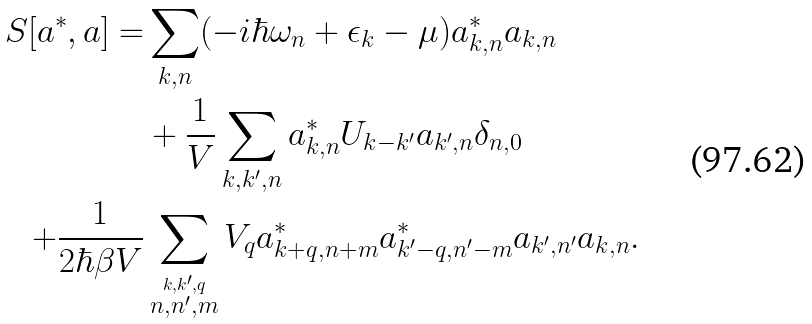Convert formula to latex. <formula><loc_0><loc_0><loc_500><loc_500>S [ a ^ { * } , a ] = & \sum _ { { k } , n } ( - i \hbar { \omega } _ { n } + \epsilon _ { k } - \mu ) a ^ { * } _ { { k } , n } a _ { { k } , n } \\ & + \frac { 1 } { V } \sum _ { { k , k ^ { \prime } } , n } a ^ { * } _ { { k } , n } U _ { { k } - { k } ^ { \prime } } a _ { { k } ^ { \prime } , n } \delta _ { n , 0 } \\ + \frac { 1 } { 2 \hbar { \beta } V } & \sum _ { \stackrel { k , k ^ { \prime } , q } { n , n ^ { \prime } , m } } V _ { q } a ^ { * } _ { { k + q } , n + m } a ^ { * } _ { { k ^ { \prime } - q } , n ^ { \prime } - m } a _ { { k ^ { \prime } } , n ^ { \prime } } a _ { { k } , n } .</formula> 